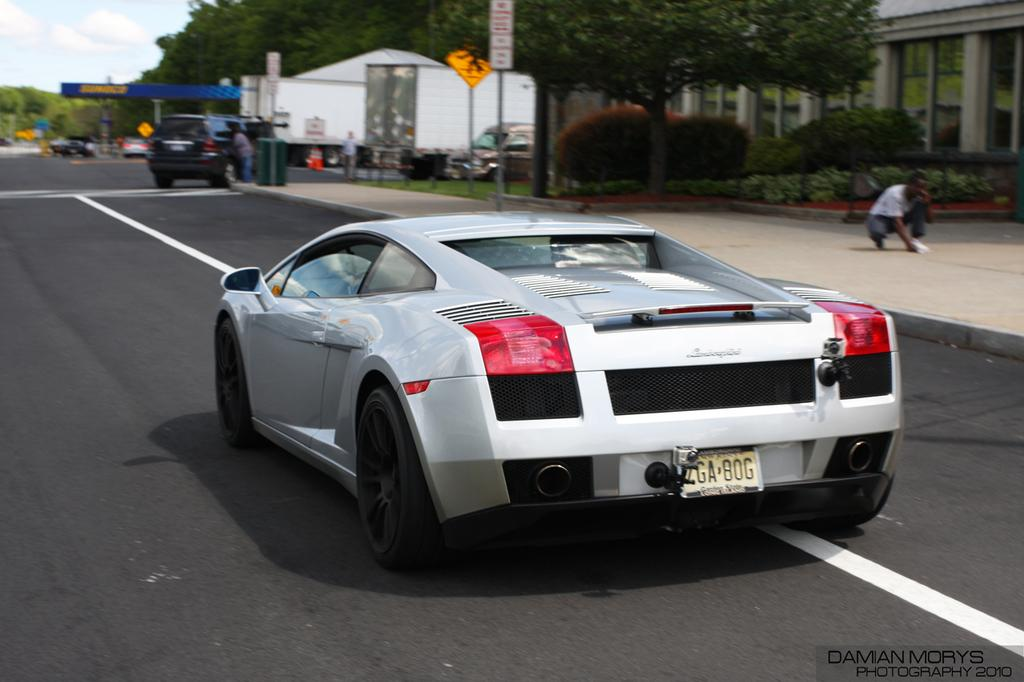What is the main feature of the image? There is a road in the image. What can be seen on the road? There are vehicles on the road. What is visible behind the road? There are trees, plants, and other constructions behind the road. How many stars can be seen in the image? There are no stars visible in the image; it features a road with vehicles and a background of trees, plants, and other constructions. 